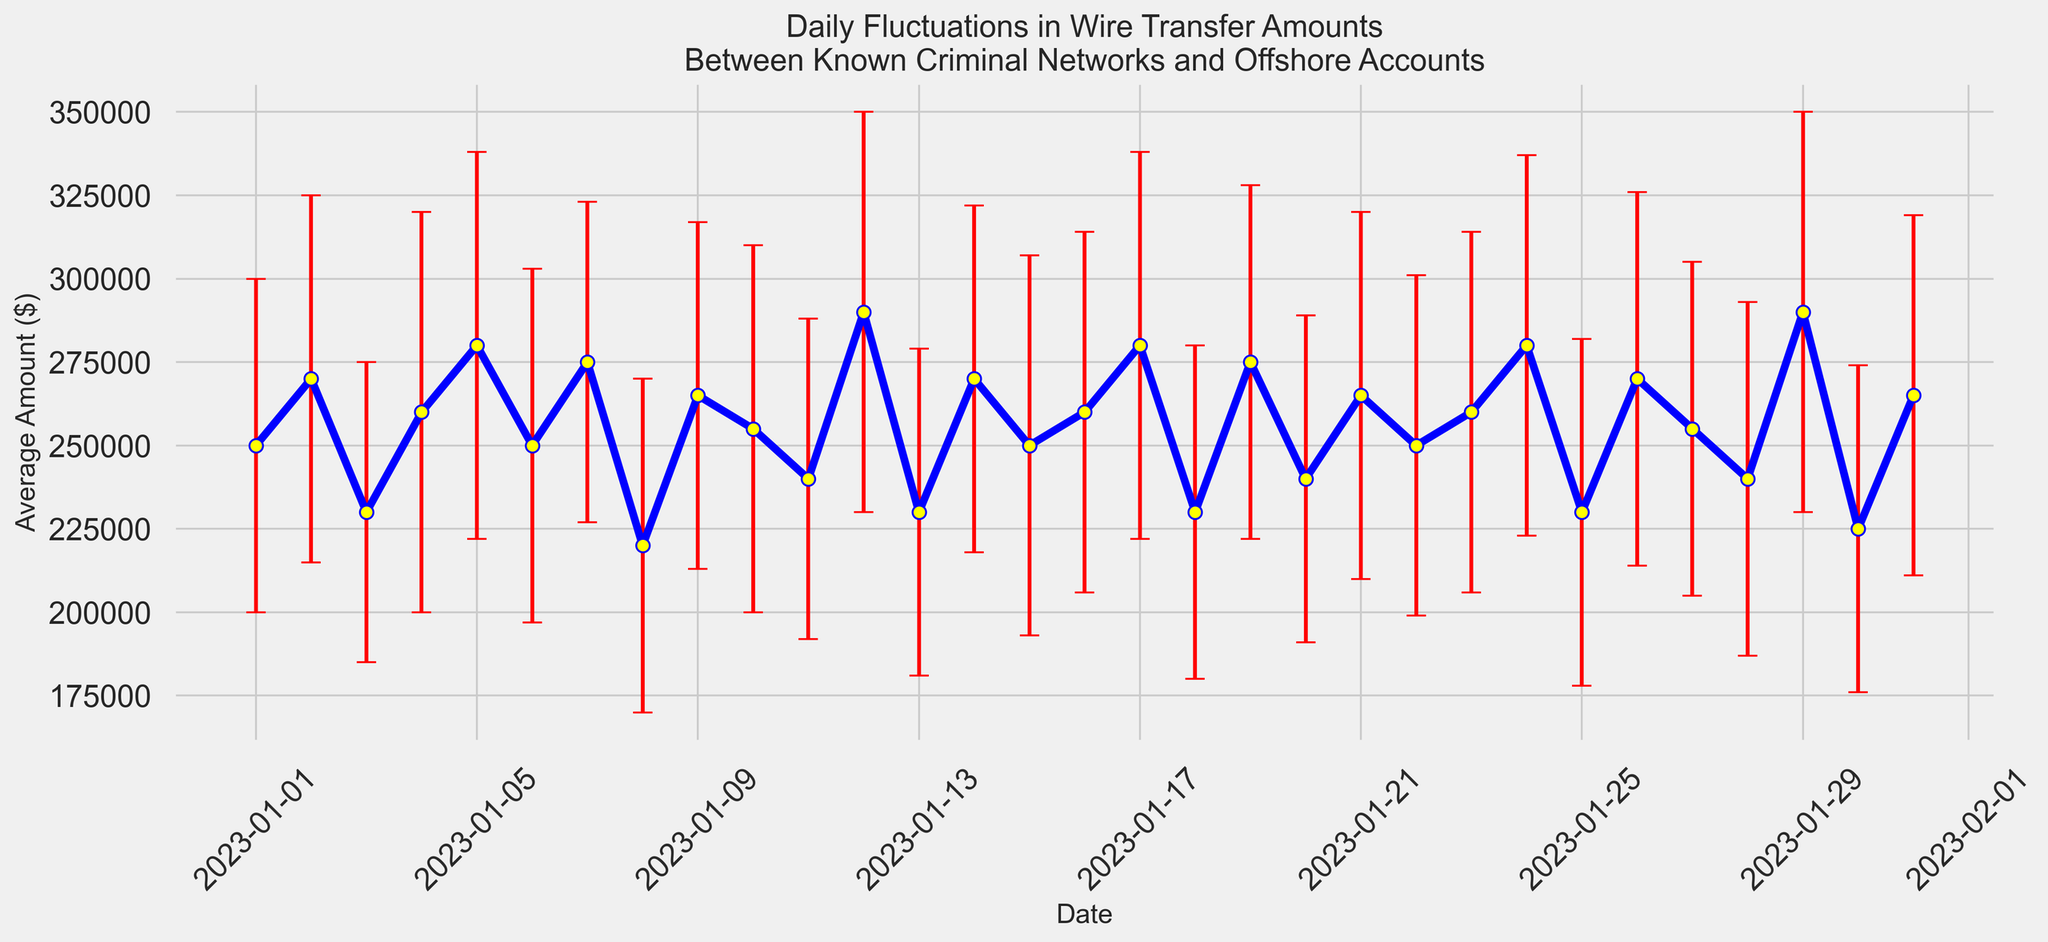Which date has the highest average wire transfer amount? To find the highest average wire transfer amount, look at the peaks in the plot. The highest point corresponds to January 12th and January 29th at $290,000.
Answer: January 12th and January 29th Which date has the lowest average wire transfer amount? To find the lowest average wire transfer amount, identify the lowest point in the plot. The lowest point corresponds to January 30th at $225,000.
Answer: January 30th What is the range of average wire transfer amounts? To calculate the range, find the difference between the highest and lowest average amounts. The highest is $290,000, and the lowest is $225,000. So, $290,000 - $225,000 = $65,000.
Answer: $65,000 On which date did the wire transfer amount fluctuate the most? The fluctuation can be determined by the length of the error bars. The date with the longest error bars corresponds to January 12th and January 29th, both with a standard deviation of $60,000.
Answer: January 12th and January 29th Compare the average wire transfer amounts between January 5th and January 28th. Which is higher? Look at the heights of the plotted points for January 5th and January 28th. January 5th's average is $280,000, and January 28th's average is $240,000. Hence, January 5th is higher.
Answer: January 5th Which dates have average wire transfer amounts exactly equal to $250,000? Identify the points that are exactly at $250,000. These correspond to January 1st, January 6th, January 15th, and January 22nd.
Answer: January 1st, January 6th, January 15th, and January 22nd Which date has the smallest standard deviation? For the smallest fluctuation, look for the shortest error bars. The smallest standard deviation corresponds to January 3rd at $45,000.
Answer: January 3rd What is the total of all average wire transfer amounts from January 1st to January 3rd? Sum the average amounts from these dates: $250,000 (Jan 1) + $270,000 (Jan 2) + $230,000 (Jan 3). So, $250,000 + $270,000 + $230,000 = $750,000.
Answer: $750,000 What is the average amount of standard deviations over the entire period? Calculate the average of the standard deviations: Total deviation sum divided by number of days. (50000+55000+45000+60000+58000+53000+48000+50000+52000+55000+48000+60000+49000+52000+57000+54000+58000+50000+53000+49000+55000+51000+54000+57000+52000+56000+50000+53000+60000+49000+54000) / 31 = 52903.23 (approx)
Answer: 52903.23 